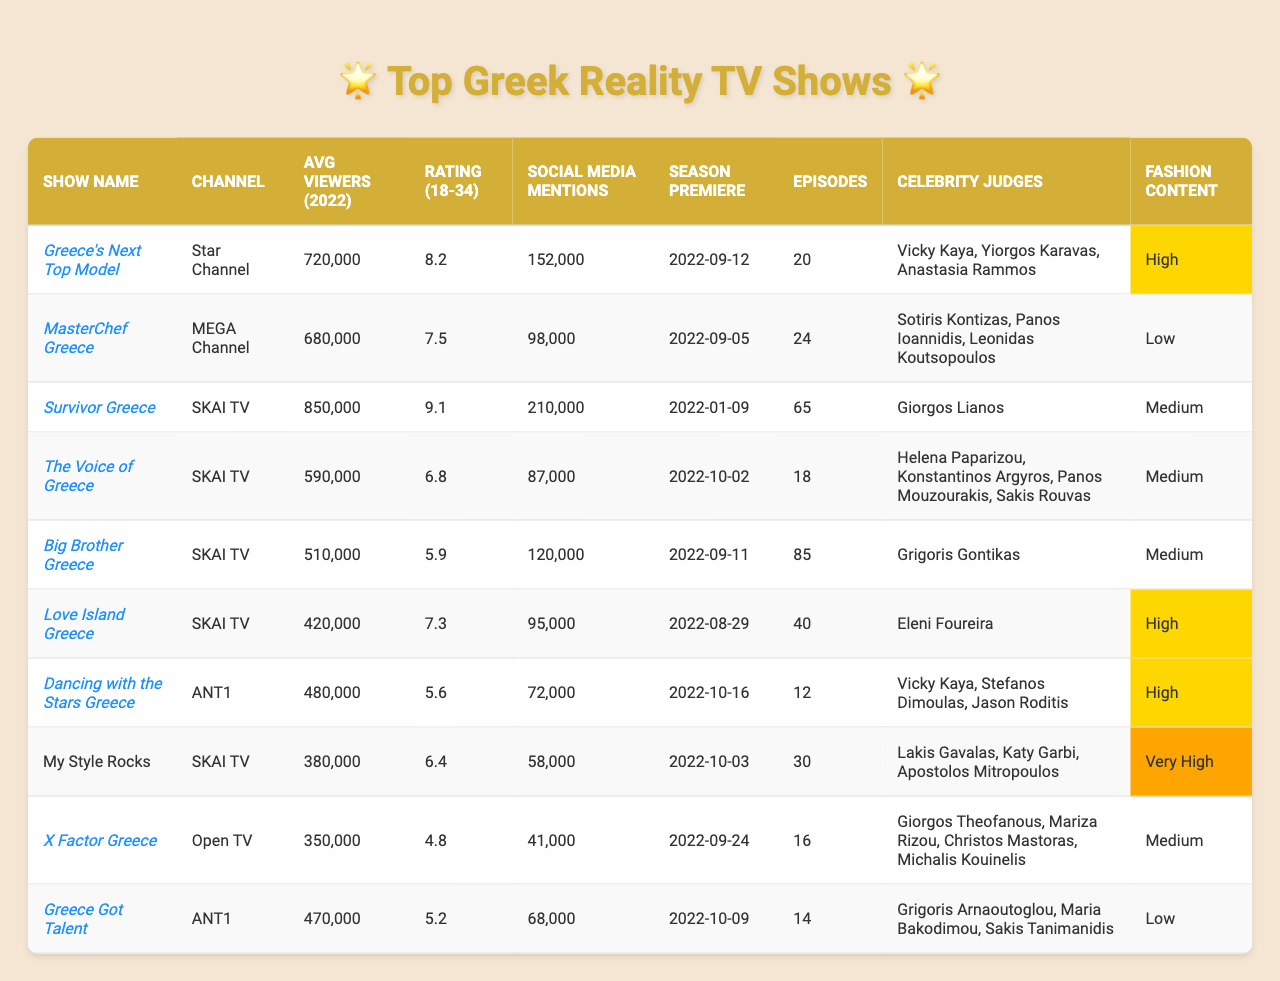What is the average viewership of "Survivor Greece"? The average viewership for "Survivor Greece" is listed in the table under the column "Avg Viewers (2022)", which shows 850,000 viewers.
Answer: 850,000 Which show has the highest rating among the 18-34 age group? The ratings for the 18-34 age group are provided in the column "Rating (18-34)". "Survivor Greece" has the highest rating at 9.1.
Answer: Survivor Greece How many episodes does "Greece Got Talent" have? The number of episodes for "Greece Got Talent" is found in the "Episodes" column, where it shows a total of 14 episodes.
Answer: 14 episodes Which channel aired the most popular show based on average viewers? "Survivor Greece" has the highest average viewers at 850,000 and it aired on SKAI TV, which appears in the "Channel" column.
Answer: SKAI TV Is "Greece's Next Top Model" considered fashion-related? The "Fashion Content" column indicates "High" for "Greece's Next Top Model", meaning it is indeed fashion-related.
Answer: Yes What is the total number of social media mentions for all shows? To find the total social media mentions, we add all the numbers in the "Social Media Mentions" column. The sum is 152,000 + 98,000 + 210,000 + 87,000 + 120,000 + 95,000 + 72,000 + 58,000 + 41,000 + 68,000, which equals 1,048,000.
Answer: 1,048,000 How does the rating of "Love Island Greece" compare to "Big Brother Greece"? "Love Island Greece" has a rating of 7.3 while "Big Brother Greece" has a rating of 5.9. Since 7.3 is greater than 5.9, "Love Island Greece" has a higher rating.
Answer: Love Island Greece is higher Which show has the lowest number of episodes? By reviewing the "Episodes" column, we see that "Dancing with the Stars Greece" has the lowest number of episodes listed at 12.
Answer: 12 episodes Are there any shows that have an international format? Checking the "International Format" column, we see that all shows except "My Style Rocks" have a true value, meaning they follow an international format.
Answer: Yes, all but one What is the average rating for shows considered "high" in fashion-related content? The shows that have "High" for fashion content are "Greece's Next Top Model", "Love Island Greece", and "Dancing with the Stars Greece". Their ratings are 8.2, 7.3, and 5.6, respectively. The average is (8.2 + 7.3 + 5.6) / 3 = 7.03.
Answer: 7.03 